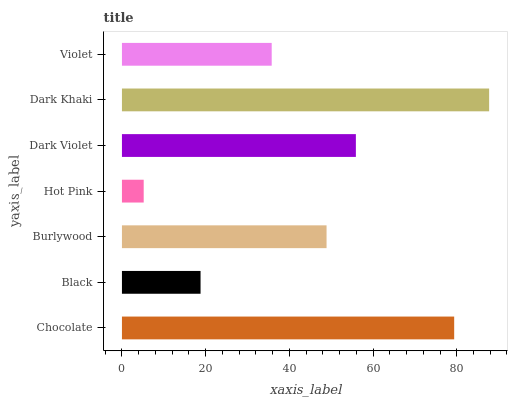Is Hot Pink the minimum?
Answer yes or no. Yes. Is Dark Khaki the maximum?
Answer yes or no. Yes. Is Black the minimum?
Answer yes or no. No. Is Black the maximum?
Answer yes or no. No. Is Chocolate greater than Black?
Answer yes or no. Yes. Is Black less than Chocolate?
Answer yes or no. Yes. Is Black greater than Chocolate?
Answer yes or no. No. Is Chocolate less than Black?
Answer yes or no. No. Is Burlywood the high median?
Answer yes or no. Yes. Is Burlywood the low median?
Answer yes or no. Yes. Is Hot Pink the high median?
Answer yes or no. No. Is Hot Pink the low median?
Answer yes or no. No. 